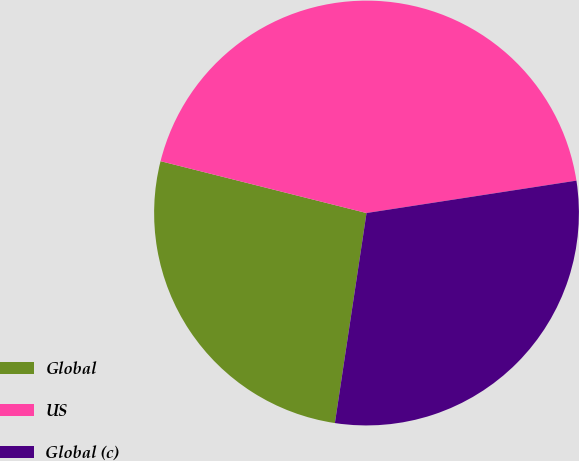Convert chart to OTSL. <chart><loc_0><loc_0><loc_500><loc_500><pie_chart><fcel>Global<fcel>US<fcel>Global (c)<nl><fcel>26.55%<fcel>43.64%<fcel>29.82%<nl></chart> 